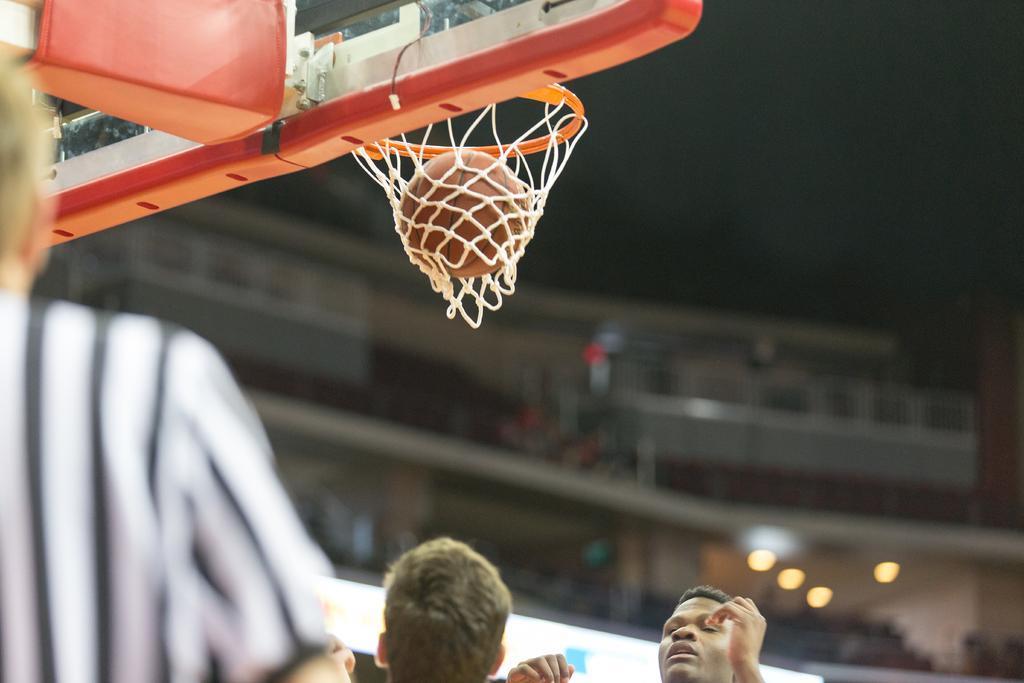In one or two sentences, can you explain what this image depicts? At the bottom of this image I can see two person´s heads. On the left side there is a person facing towards the back side. At the top of the image there is a basketball hoop and there is a ball in the net. The background is blurred. In the background there is a building and few lights. 